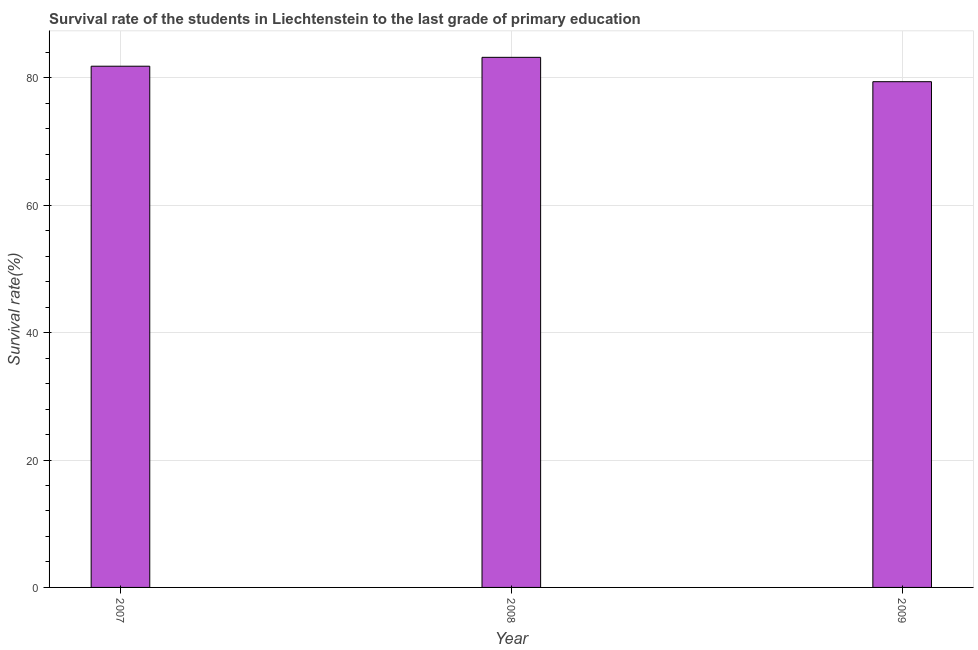Does the graph contain grids?
Give a very brief answer. Yes. What is the title of the graph?
Offer a very short reply. Survival rate of the students in Liechtenstein to the last grade of primary education. What is the label or title of the Y-axis?
Offer a very short reply. Survival rate(%). What is the survival rate in primary education in 2008?
Your answer should be compact. 83.22. Across all years, what is the maximum survival rate in primary education?
Your response must be concise. 83.22. Across all years, what is the minimum survival rate in primary education?
Offer a very short reply. 79.4. In which year was the survival rate in primary education minimum?
Make the answer very short. 2009. What is the sum of the survival rate in primary education?
Offer a terse response. 244.45. What is the difference between the survival rate in primary education in 2007 and 2008?
Give a very brief answer. -1.39. What is the average survival rate in primary education per year?
Your response must be concise. 81.48. What is the median survival rate in primary education?
Keep it short and to the point. 81.83. In how many years, is the survival rate in primary education greater than 68 %?
Make the answer very short. 3. Do a majority of the years between 2009 and 2007 (inclusive) have survival rate in primary education greater than 76 %?
Provide a short and direct response. Yes. What is the ratio of the survival rate in primary education in 2008 to that in 2009?
Provide a succinct answer. 1.05. Is the difference between the survival rate in primary education in 2007 and 2009 greater than the difference between any two years?
Offer a very short reply. No. What is the difference between the highest and the second highest survival rate in primary education?
Keep it short and to the point. 1.39. What is the difference between the highest and the lowest survival rate in primary education?
Your answer should be compact. 3.82. How many bars are there?
Your answer should be compact. 3. How many years are there in the graph?
Your answer should be very brief. 3. What is the Survival rate(%) in 2007?
Offer a terse response. 81.83. What is the Survival rate(%) in 2008?
Provide a short and direct response. 83.22. What is the Survival rate(%) of 2009?
Provide a short and direct response. 79.4. What is the difference between the Survival rate(%) in 2007 and 2008?
Offer a very short reply. -1.39. What is the difference between the Survival rate(%) in 2007 and 2009?
Provide a succinct answer. 2.43. What is the difference between the Survival rate(%) in 2008 and 2009?
Offer a very short reply. 3.82. What is the ratio of the Survival rate(%) in 2007 to that in 2008?
Offer a terse response. 0.98. What is the ratio of the Survival rate(%) in 2007 to that in 2009?
Offer a terse response. 1.03. What is the ratio of the Survival rate(%) in 2008 to that in 2009?
Your answer should be very brief. 1.05. 